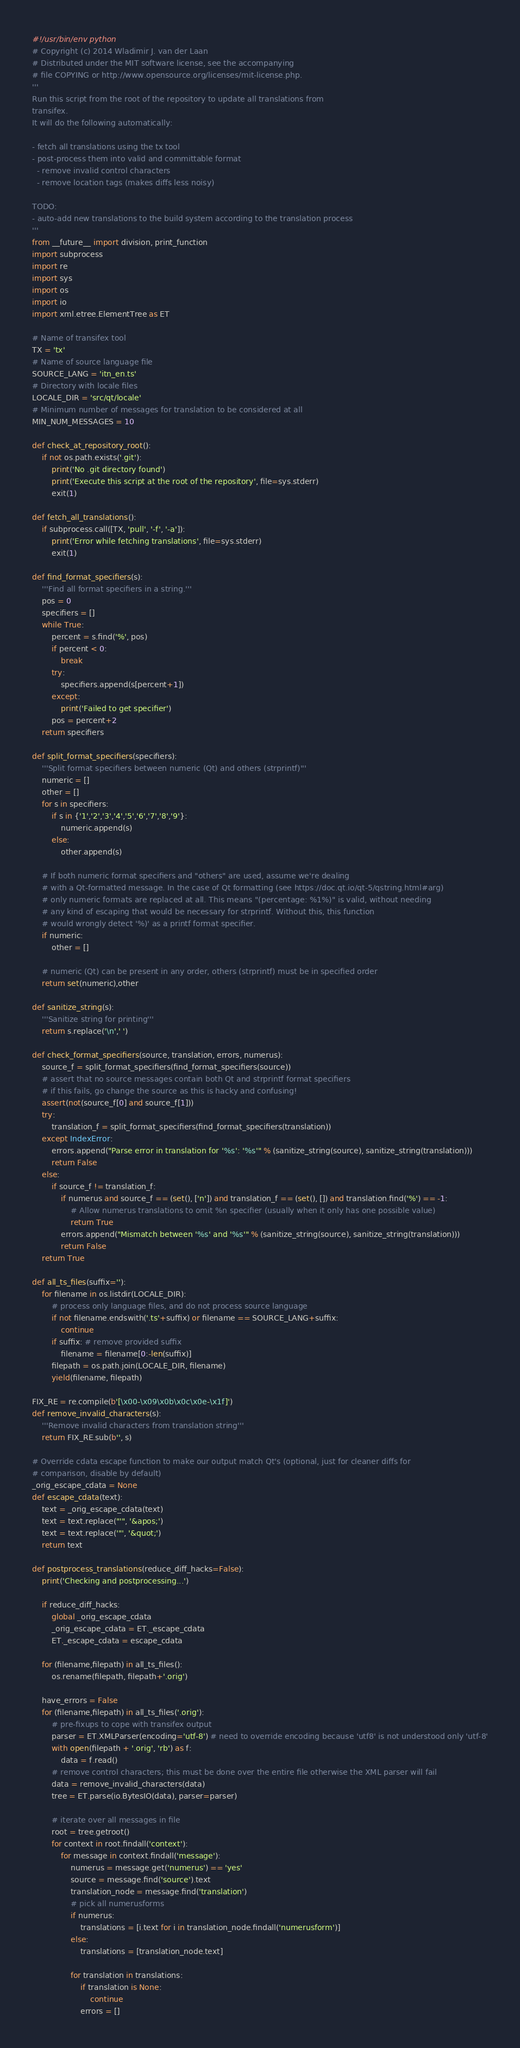<code> <loc_0><loc_0><loc_500><loc_500><_Python_>#!/usr/bin/env python
# Copyright (c) 2014 Wladimir J. van der Laan
# Distributed under the MIT software license, see the accompanying
# file COPYING or http://www.opensource.org/licenses/mit-license.php.
'''
Run this script from the root of the repository to update all translations from
transifex.
It will do the following automatically:

- fetch all translations using the tx tool
- post-process them into valid and committable format
  - remove invalid control characters
  - remove location tags (makes diffs less noisy)

TODO:
- auto-add new translations to the build system according to the translation process
'''
from __future__ import division, print_function
import subprocess
import re
import sys
import os
import io
import xml.etree.ElementTree as ET

# Name of transifex tool
TX = 'tx'
# Name of source language file
SOURCE_LANG = 'itn_en.ts'
# Directory with locale files
LOCALE_DIR = 'src/qt/locale'
# Minimum number of messages for translation to be considered at all
MIN_NUM_MESSAGES = 10

def check_at_repository_root():
    if not os.path.exists('.git'):
        print('No .git directory found')
        print('Execute this script at the root of the repository', file=sys.stderr)
        exit(1)

def fetch_all_translations():
    if subprocess.call([TX, 'pull', '-f', '-a']):
        print('Error while fetching translations', file=sys.stderr)
        exit(1)

def find_format_specifiers(s):
    '''Find all format specifiers in a string.'''
    pos = 0
    specifiers = []
    while True:
        percent = s.find('%', pos)
        if percent < 0:
            break
        try:
            specifiers.append(s[percent+1])
        except:
            print('Failed to get specifier')
        pos = percent+2
    return specifiers

def split_format_specifiers(specifiers):
    '''Split format specifiers between numeric (Qt) and others (strprintf)'''
    numeric = []
    other = []
    for s in specifiers:
        if s in {'1','2','3','4','5','6','7','8','9'}:
            numeric.append(s)
        else:
            other.append(s)

    # If both numeric format specifiers and "others" are used, assume we're dealing
    # with a Qt-formatted message. In the case of Qt formatting (see https://doc.qt.io/qt-5/qstring.html#arg)
    # only numeric formats are replaced at all. This means "(percentage: %1%)" is valid, without needing
    # any kind of escaping that would be necessary for strprintf. Without this, this function
    # would wrongly detect '%)' as a printf format specifier.
    if numeric:
        other = []

    # numeric (Qt) can be present in any order, others (strprintf) must be in specified order
    return set(numeric),other

def sanitize_string(s):
    '''Sanitize string for printing'''
    return s.replace('\n',' ')

def check_format_specifiers(source, translation, errors, numerus):
    source_f = split_format_specifiers(find_format_specifiers(source))
    # assert that no source messages contain both Qt and strprintf format specifiers
    # if this fails, go change the source as this is hacky and confusing!
    assert(not(source_f[0] and source_f[1]))
    try:
        translation_f = split_format_specifiers(find_format_specifiers(translation))
    except IndexError:
        errors.append("Parse error in translation for '%s': '%s'" % (sanitize_string(source), sanitize_string(translation)))
        return False
    else:
        if source_f != translation_f:
            if numerus and source_f == (set(), ['n']) and translation_f == (set(), []) and translation.find('%') == -1:
                # Allow numerus translations to omit %n specifier (usually when it only has one possible value)
                return True
            errors.append("Mismatch between '%s' and '%s'" % (sanitize_string(source), sanitize_string(translation)))
            return False
    return True

def all_ts_files(suffix=''):
    for filename in os.listdir(LOCALE_DIR):
        # process only language files, and do not process source language
        if not filename.endswith('.ts'+suffix) or filename == SOURCE_LANG+suffix:
            continue
        if suffix: # remove provided suffix
            filename = filename[0:-len(suffix)]
        filepath = os.path.join(LOCALE_DIR, filename)
        yield(filename, filepath)

FIX_RE = re.compile(b'[\x00-\x09\x0b\x0c\x0e-\x1f]')
def remove_invalid_characters(s):
    '''Remove invalid characters from translation string'''
    return FIX_RE.sub(b'', s)

# Override cdata escape function to make our output match Qt's (optional, just for cleaner diffs for
# comparison, disable by default)
_orig_escape_cdata = None
def escape_cdata(text):
    text = _orig_escape_cdata(text)
    text = text.replace("'", '&apos;')
    text = text.replace('"', '&quot;')
    return text

def postprocess_translations(reduce_diff_hacks=False):
    print('Checking and postprocessing...')

    if reduce_diff_hacks:
        global _orig_escape_cdata
        _orig_escape_cdata = ET._escape_cdata
        ET._escape_cdata = escape_cdata

    for (filename,filepath) in all_ts_files():
        os.rename(filepath, filepath+'.orig')

    have_errors = False
    for (filename,filepath) in all_ts_files('.orig'):
        # pre-fixups to cope with transifex output
        parser = ET.XMLParser(encoding='utf-8') # need to override encoding because 'utf8' is not understood only 'utf-8'
        with open(filepath + '.orig', 'rb') as f:
            data = f.read()
        # remove control characters; this must be done over the entire file otherwise the XML parser will fail
        data = remove_invalid_characters(data)
        tree = ET.parse(io.BytesIO(data), parser=parser)

        # iterate over all messages in file
        root = tree.getroot()
        for context in root.findall('context'):
            for message in context.findall('message'):
                numerus = message.get('numerus') == 'yes'
                source = message.find('source').text
                translation_node = message.find('translation')
                # pick all numerusforms
                if numerus:
                    translations = [i.text for i in translation_node.findall('numerusform')]
                else:
                    translations = [translation_node.text]

                for translation in translations:
                    if translation is None:
                        continue
                    errors = []</code> 